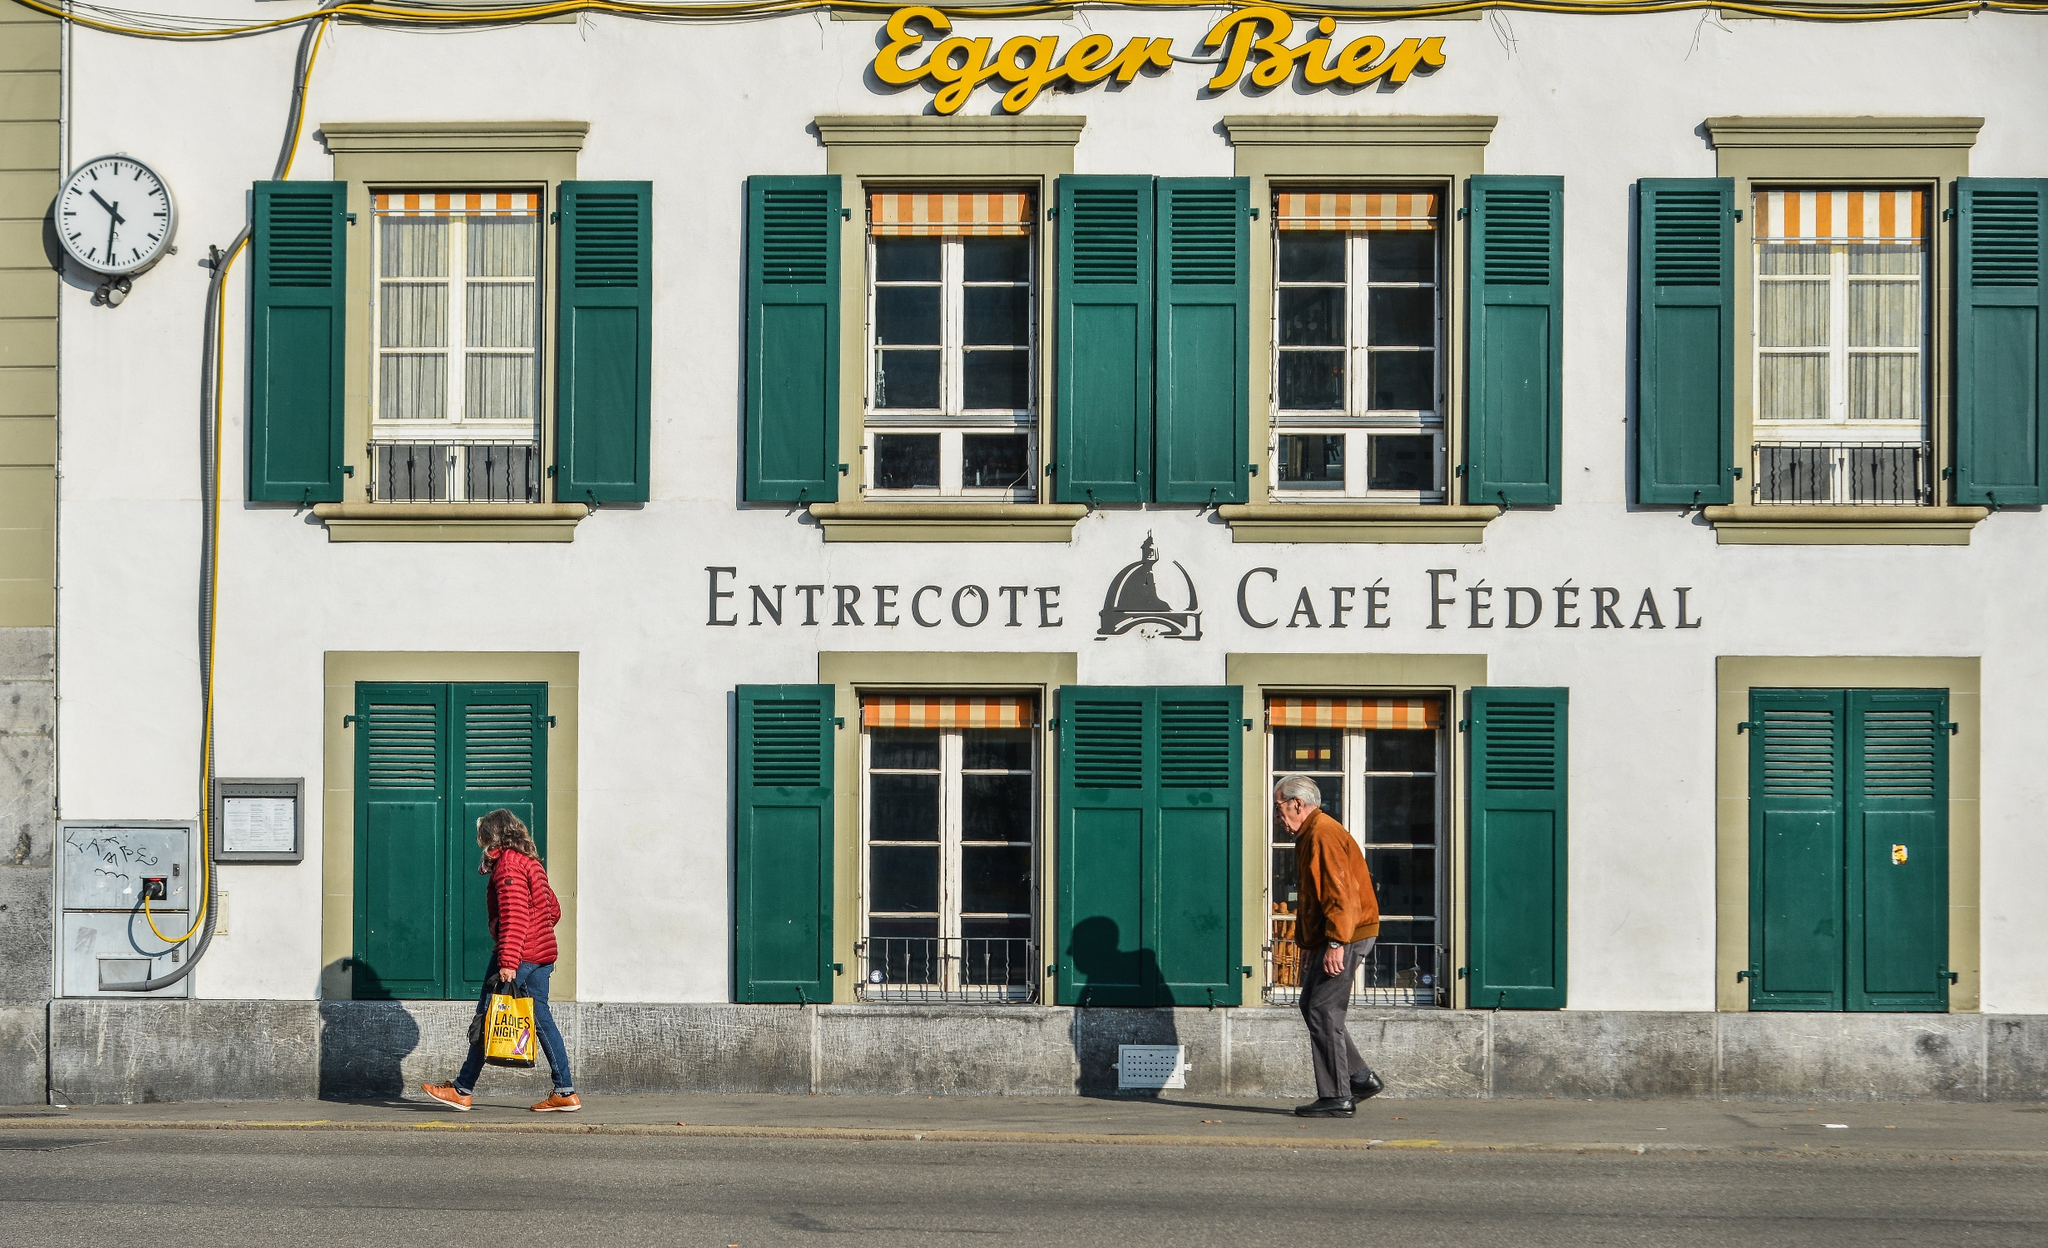Describe an ordinary day for a passerby. For a passerby, an ordinary day might involve strolling past 'Entrecote Café Fédéral' on their way to work or errands. They might glance at the clock to check the time, take in the charming facade and the bustling activity of the café, and perhaps wave at familiar faces or enjoy the sights and sounds of a typical day in this quaint Swiss town. 